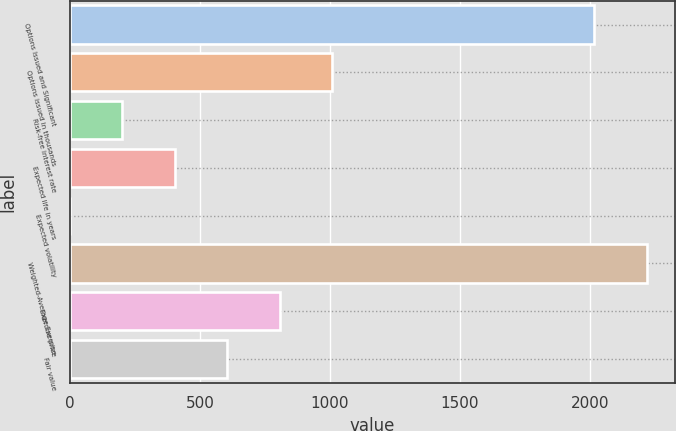Convert chart. <chart><loc_0><loc_0><loc_500><loc_500><bar_chart><fcel>Options Issued and Significant<fcel>Options issued in thousands<fcel>Risk-free interest rate<fcel>Expected life in years<fcel>Expected volatility<fcel>Weighted-Average Exercise<fcel>Exercise price<fcel>Fair value<nl><fcel>2016<fcel>1008.15<fcel>201.83<fcel>403.41<fcel>0.25<fcel>2217.57<fcel>806.57<fcel>604.99<nl></chart> 